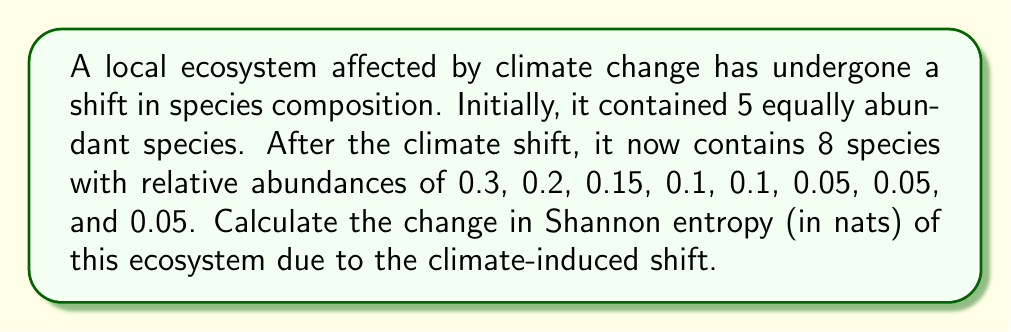Provide a solution to this math problem. To solve this problem, we need to calculate the Shannon entropy before and after the climate shift, then find the difference.

Step 1: Calculate initial Shannon entropy
For 5 equally abundant species, the probability of each species is 1/5 = 0.2
Initial Shannon entropy:
$$H_1 = -\sum_{i=1}^{5} p_i \ln(p_i) = -5 \cdot (0.2 \ln(0.2)) = -5 \cdot (-1.6094) = 1.6094 \text{ nats}$$

Step 2: Calculate final Shannon entropy
For 8 species with given relative abundances:
$$H_2 = -\sum_{i=1}^{8} p_i \ln(p_i)$$
$$= -(0.3 \ln(0.3) + 0.2 \ln(0.2) + 0.15 \ln(0.15) + 2 \cdot 0.1 \ln(0.1) + 3 \cdot 0.05 \ln(0.05))$$
$$= -(-0.3611 - 0.3219 - 0.2849 - 0.4605 - 0.4479)$$
$$= 1.8763 \text{ nats}$$

Step 3: Calculate the change in Shannon entropy
$$\Delta H = H_2 - H_1 = 1.8763 - 1.6094 = 0.2669 \text{ nats}$$
Answer: 0.2669 nats 